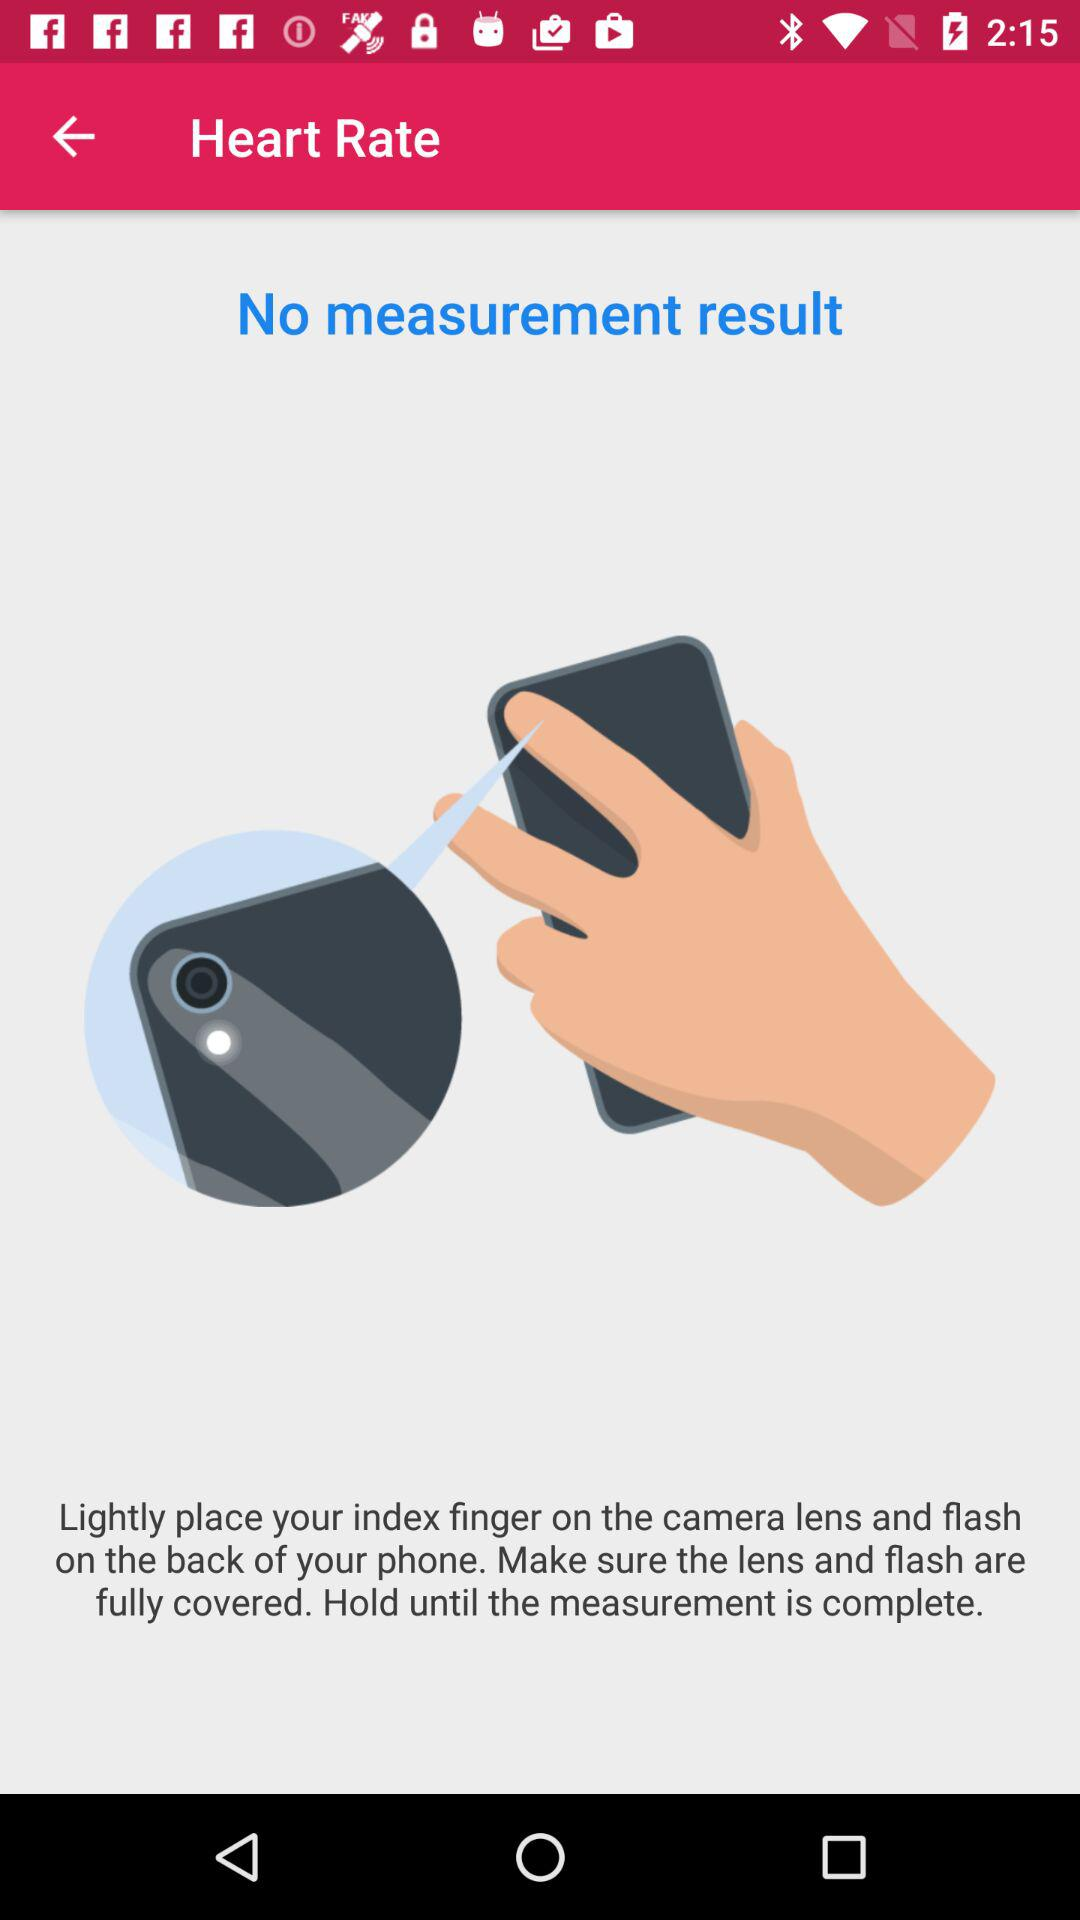What is the name of the application?
When the provided information is insufficient, respond with <no answer>. <no answer> 